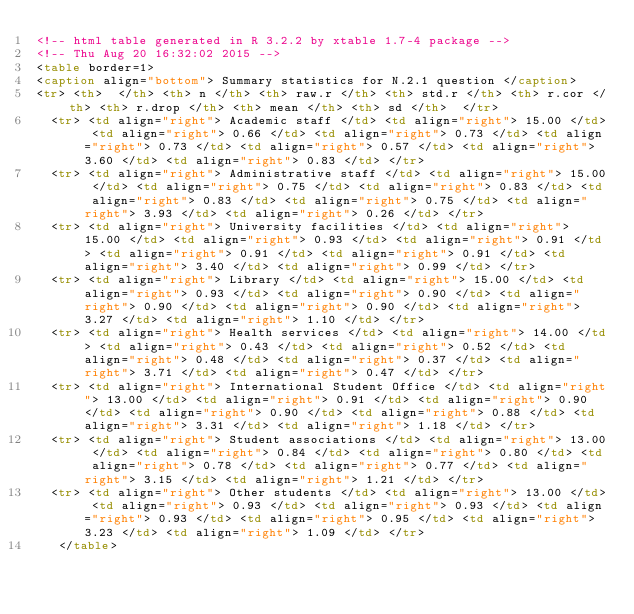<code> <loc_0><loc_0><loc_500><loc_500><_HTML_><!-- html table generated in R 3.2.2 by xtable 1.7-4 package -->
<!-- Thu Aug 20 16:32:02 2015 -->
<table border=1>
<caption align="bottom"> Summary statistics for N.2.1 question </caption>
<tr> <th>  </th> <th> n </th> <th> raw.r </th> <th> std.r </th> <th> r.cor </th> <th> r.drop </th> <th> mean </th> <th> sd </th>  </tr>
  <tr> <td align="right"> Academic staff </td> <td align="right"> 15.00 </td> <td align="right"> 0.66 </td> <td align="right"> 0.73 </td> <td align="right"> 0.73 </td> <td align="right"> 0.57 </td> <td align="right"> 3.60 </td> <td align="right"> 0.83 </td> </tr>
  <tr> <td align="right"> Administrative staff </td> <td align="right"> 15.00 </td> <td align="right"> 0.75 </td> <td align="right"> 0.83 </td> <td align="right"> 0.83 </td> <td align="right"> 0.75 </td> <td align="right"> 3.93 </td> <td align="right"> 0.26 </td> </tr>
  <tr> <td align="right"> University facilities </td> <td align="right"> 15.00 </td> <td align="right"> 0.93 </td> <td align="right"> 0.91 </td> <td align="right"> 0.91 </td> <td align="right"> 0.91 </td> <td align="right"> 3.40 </td> <td align="right"> 0.99 </td> </tr>
  <tr> <td align="right"> Library </td> <td align="right"> 15.00 </td> <td align="right"> 0.93 </td> <td align="right"> 0.90 </td> <td align="right"> 0.90 </td> <td align="right"> 0.90 </td> <td align="right"> 3.27 </td> <td align="right"> 1.10 </td> </tr>
  <tr> <td align="right"> Health services </td> <td align="right"> 14.00 </td> <td align="right"> 0.43 </td> <td align="right"> 0.52 </td> <td align="right"> 0.48 </td> <td align="right"> 0.37 </td> <td align="right"> 3.71 </td> <td align="right"> 0.47 </td> </tr>
  <tr> <td align="right"> International Student Office </td> <td align="right"> 13.00 </td> <td align="right"> 0.91 </td> <td align="right"> 0.90 </td> <td align="right"> 0.90 </td> <td align="right"> 0.88 </td> <td align="right"> 3.31 </td> <td align="right"> 1.18 </td> </tr>
  <tr> <td align="right"> Student associations </td> <td align="right"> 13.00 </td> <td align="right"> 0.84 </td> <td align="right"> 0.80 </td> <td align="right"> 0.78 </td> <td align="right"> 0.77 </td> <td align="right"> 3.15 </td> <td align="right"> 1.21 </td> </tr>
  <tr> <td align="right"> Other students </td> <td align="right"> 13.00 </td> <td align="right"> 0.93 </td> <td align="right"> 0.93 </td> <td align="right"> 0.93 </td> <td align="right"> 0.95 </td> <td align="right"> 3.23 </td> <td align="right"> 1.09 </td> </tr>
   </table>
</code> 